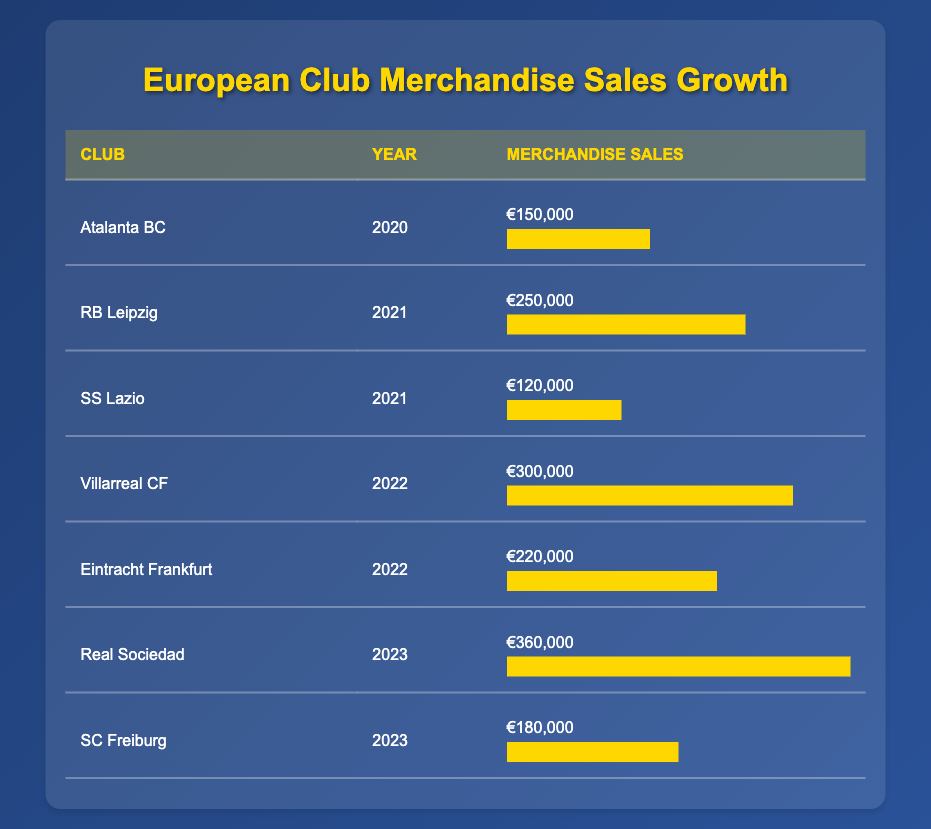What was the merchandise sales of Villarreal CF in 2022? The table shows that Villarreal CF had merchandise sales of €300,000 in the year 2022.
Answer: €300,000 Did SC Freiburg have higher merchandise sales than Atalanta BC? SC Freiburg's sales were €180,000 while Atalanta BC's were €150,000. Since €180,000 is greater than €150,000, SC Freiburg did have higher sales.
Answer: Yes What is the total merchandise sales of both RB Leipzig and SS Lazio in 2021? RB Leipzig had sales of €250,000 and SS Lazio had sales of €120,000. Adding both gives €250,000 + €120,000 = €370,000.
Answer: €370,000 Which club had the highest merchandise sales and what was the amount? Referring to the table, Real Sociedad had the highest sales of €360,000 in 2023.
Answer: Real Sociedad, €360,000 What was the average merchandise sales for clubs in 2022? The clubs listed in 2022 are Villarreal CF (€300,000) and Eintracht Frankfurt (€220,000). First, sum them up: €300,000 + €220,000 = €520,000. Then, divide by the number of clubs (2): €520,000 / 2 = €260,000.
Answer: €260,000 Did every club listed in 2023 have increasing merchandise sales from their previous year's sales? In 2023, Real Sociedad's sales are €360,000 and SC Freiburg's are €180,000. Comparing to the previous years, SC Freiburg's sales in 2023 (€180,000) rose from €150,000 (Atalanta BC) in 2020, but we can't compare directly with any prior year due to lack of data for 2022. So we conclude it cannot be determined if both clubs increased sales.
Answer: No 